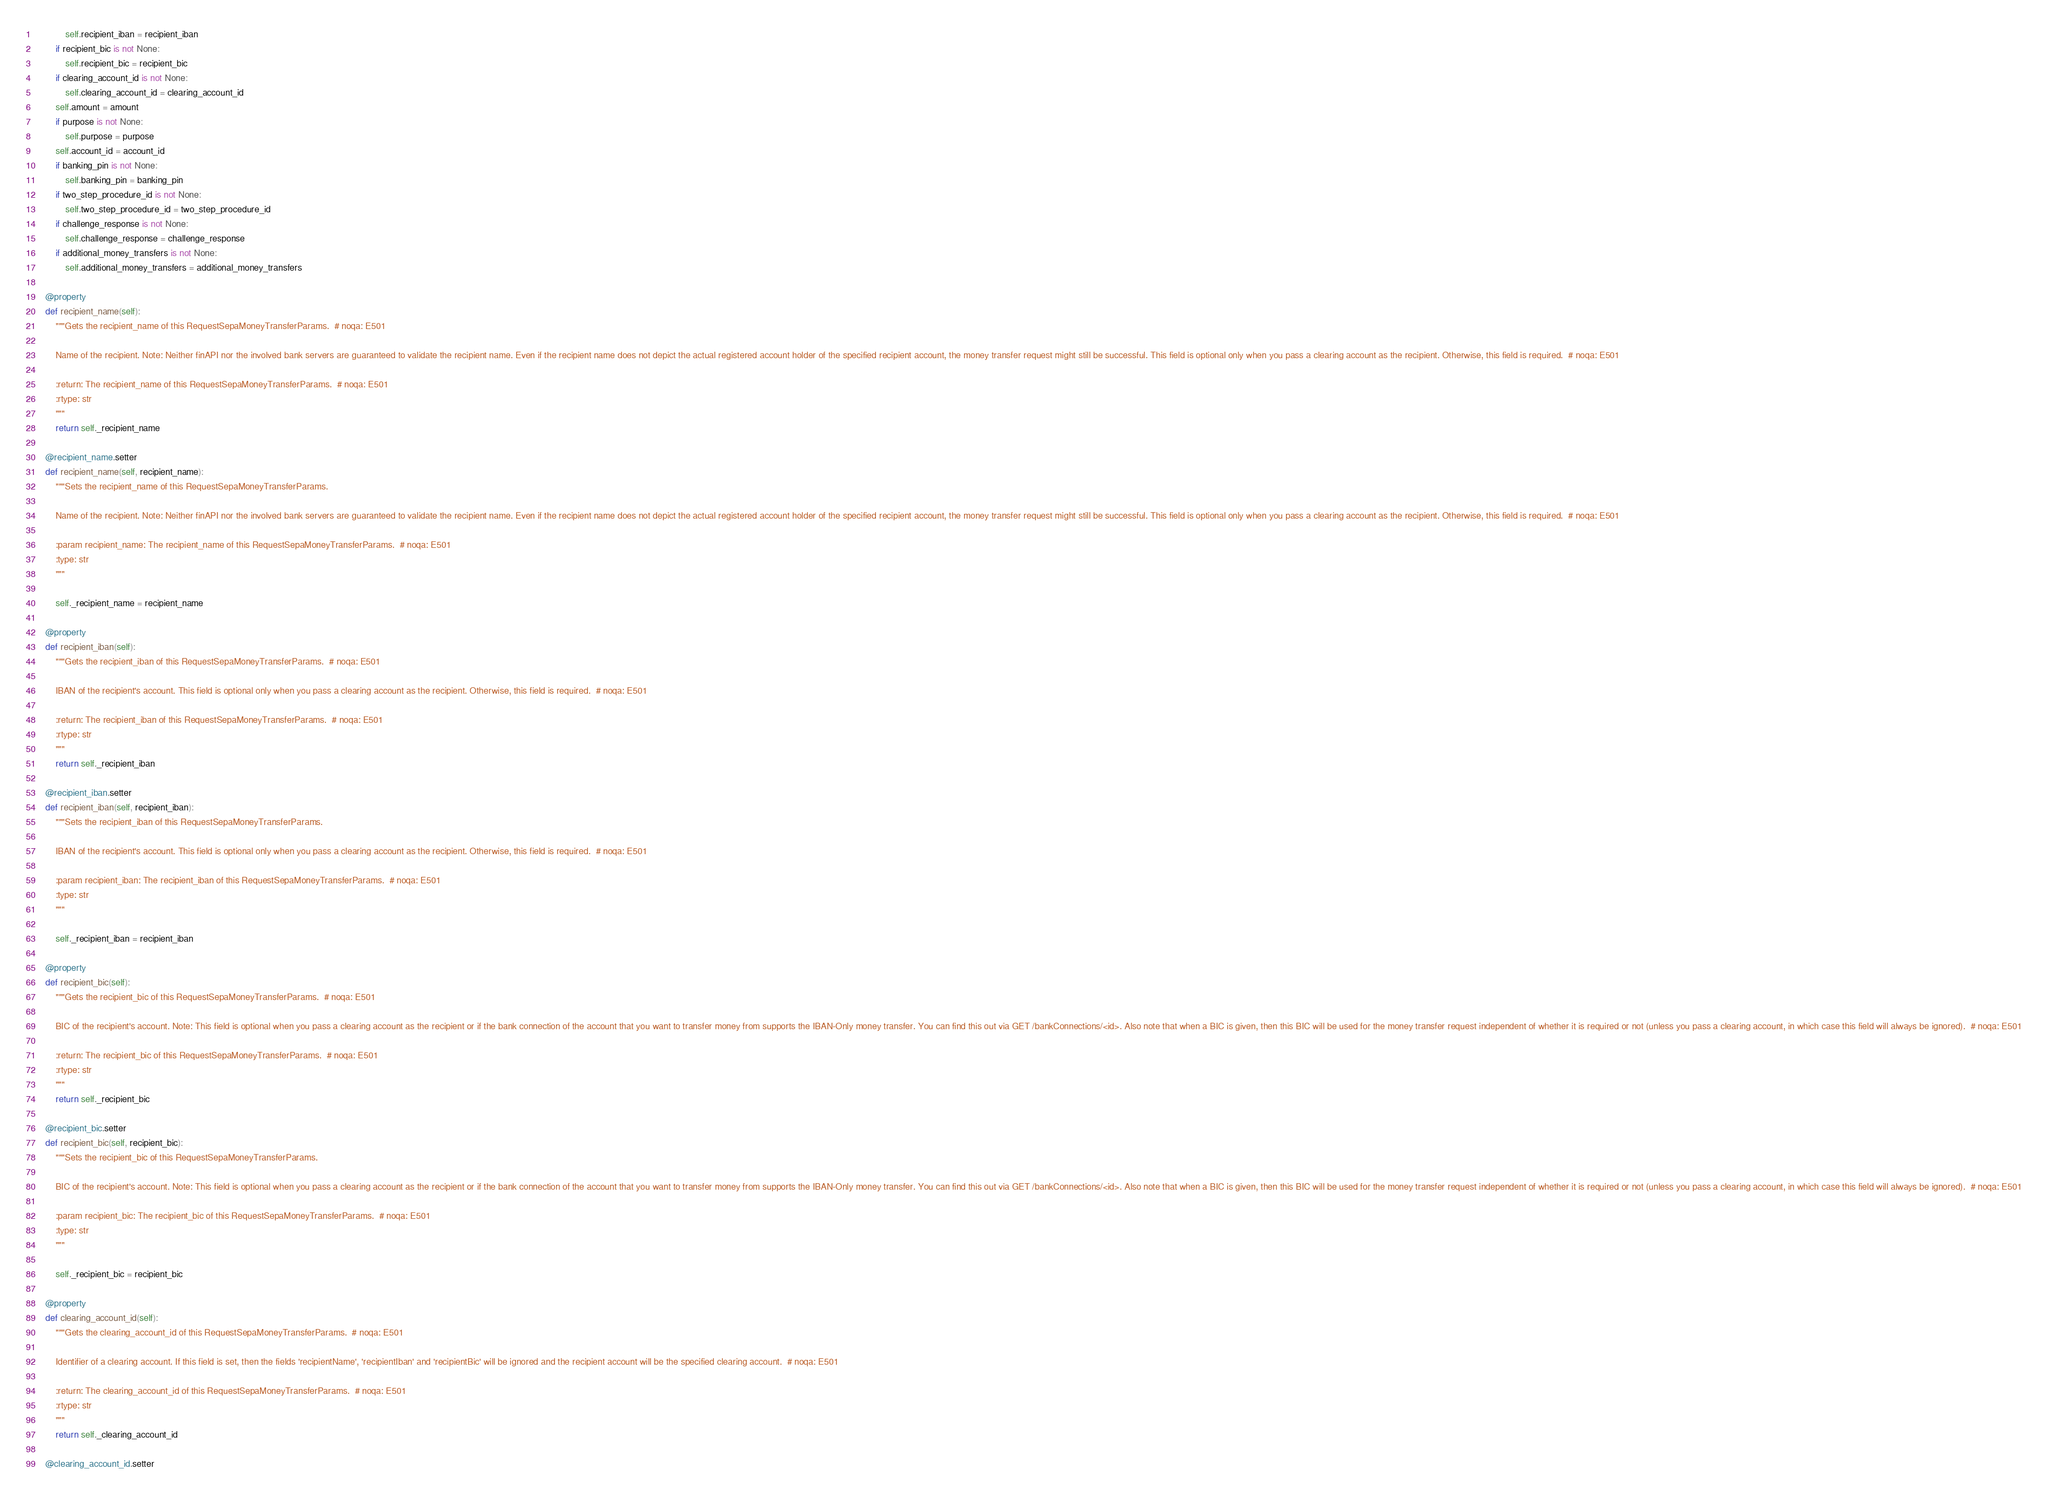<code> <loc_0><loc_0><loc_500><loc_500><_Python_>            self.recipient_iban = recipient_iban
        if recipient_bic is not None:
            self.recipient_bic = recipient_bic
        if clearing_account_id is not None:
            self.clearing_account_id = clearing_account_id
        self.amount = amount
        if purpose is not None:
            self.purpose = purpose
        self.account_id = account_id
        if banking_pin is not None:
            self.banking_pin = banking_pin
        if two_step_procedure_id is not None:
            self.two_step_procedure_id = two_step_procedure_id
        if challenge_response is not None:
            self.challenge_response = challenge_response
        if additional_money_transfers is not None:
            self.additional_money_transfers = additional_money_transfers

    @property
    def recipient_name(self):
        """Gets the recipient_name of this RequestSepaMoneyTransferParams.  # noqa: E501

        Name of the recipient. Note: Neither finAPI nor the involved bank servers are guaranteed to validate the recipient name. Even if the recipient name does not depict the actual registered account holder of the specified recipient account, the money transfer request might still be successful. This field is optional only when you pass a clearing account as the recipient. Otherwise, this field is required.  # noqa: E501

        :return: The recipient_name of this RequestSepaMoneyTransferParams.  # noqa: E501
        :rtype: str
        """
        return self._recipient_name

    @recipient_name.setter
    def recipient_name(self, recipient_name):
        """Sets the recipient_name of this RequestSepaMoneyTransferParams.

        Name of the recipient. Note: Neither finAPI nor the involved bank servers are guaranteed to validate the recipient name. Even if the recipient name does not depict the actual registered account holder of the specified recipient account, the money transfer request might still be successful. This field is optional only when you pass a clearing account as the recipient. Otherwise, this field is required.  # noqa: E501

        :param recipient_name: The recipient_name of this RequestSepaMoneyTransferParams.  # noqa: E501
        :type: str
        """

        self._recipient_name = recipient_name

    @property
    def recipient_iban(self):
        """Gets the recipient_iban of this RequestSepaMoneyTransferParams.  # noqa: E501

        IBAN of the recipient's account. This field is optional only when you pass a clearing account as the recipient. Otherwise, this field is required.  # noqa: E501

        :return: The recipient_iban of this RequestSepaMoneyTransferParams.  # noqa: E501
        :rtype: str
        """
        return self._recipient_iban

    @recipient_iban.setter
    def recipient_iban(self, recipient_iban):
        """Sets the recipient_iban of this RequestSepaMoneyTransferParams.

        IBAN of the recipient's account. This field is optional only when you pass a clearing account as the recipient. Otherwise, this field is required.  # noqa: E501

        :param recipient_iban: The recipient_iban of this RequestSepaMoneyTransferParams.  # noqa: E501
        :type: str
        """

        self._recipient_iban = recipient_iban

    @property
    def recipient_bic(self):
        """Gets the recipient_bic of this RequestSepaMoneyTransferParams.  # noqa: E501

        BIC of the recipient's account. Note: This field is optional when you pass a clearing account as the recipient or if the bank connection of the account that you want to transfer money from supports the IBAN-Only money transfer. You can find this out via GET /bankConnections/<id>. Also note that when a BIC is given, then this BIC will be used for the money transfer request independent of whether it is required or not (unless you pass a clearing account, in which case this field will always be ignored).  # noqa: E501

        :return: The recipient_bic of this RequestSepaMoneyTransferParams.  # noqa: E501
        :rtype: str
        """
        return self._recipient_bic

    @recipient_bic.setter
    def recipient_bic(self, recipient_bic):
        """Sets the recipient_bic of this RequestSepaMoneyTransferParams.

        BIC of the recipient's account. Note: This field is optional when you pass a clearing account as the recipient or if the bank connection of the account that you want to transfer money from supports the IBAN-Only money transfer. You can find this out via GET /bankConnections/<id>. Also note that when a BIC is given, then this BIC will be used for the money transfer request independent of whether it is required or not (unless you pass a clearing account, in which case this field will always be ignored).  # noqa: E501

        :param recipient_bic: The recipient_bic of this RequestSepaMoneyTransferParams.  # noqa: E501
        :type: str
        """

        self._recipient_bic = recipient_bic

    @property
    def clearing_account_id(self):
        """Gets the clearing_account_id of this RequestSepaMoneyTransferParams.  # noqa: E501

        Identifier of a clearing account. If this field is set, then the fields 'recipientName', 'recipientIban' and 'recipientBic' will be ignored and the recipient account will be the specified clearing account.  # noqa: E501

        :return: The clearing_account_id of this RequestSepaMoneyTransferParams.  # noqa: E501
        :rtype: str
        """
        return self._clearing_account_id

    @clearing_account_id.setter</code> 